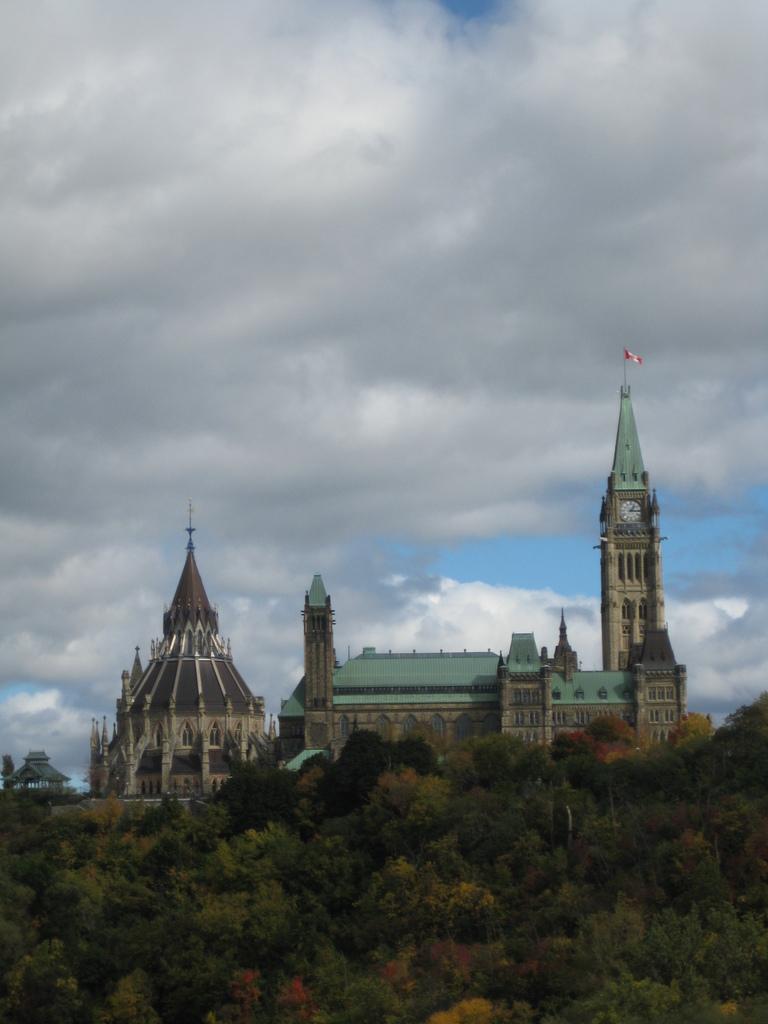Please provide a concise description of this image. In the center of the image there is a building. There are trees. In the background of the image there is sky and clouds. 